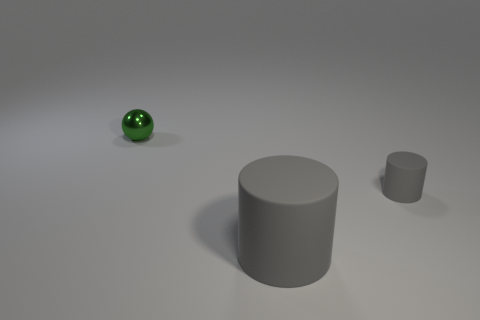There is another cylinder that is the same color as the big cylinder; what size is it?
Your response must be concise. Small. What color is the rubber cylinder that is the same size as the green thing?
Provide a short and direct response. Gray. Does the tiny metal sphere have the same color as the matte object that is behind the big cylinder?
Keep it short and to the point. No. There is a tiny thing on the right side of the green object; what is it made of?
Keep it short and to the point. Rubber. What is the size of the other object that is the same shape as the large object?
Your answer should be compact. Small. There is another rubber object that is the same shape as the small rubber thing; what is its color?
Make the answer very short. Gray. There is a tiny thing that is in front of the green metallic thing; is its color the same as the metal ball?
Offer a terse response. No. What is the shape of the big thing that is made of the same material as the small gray object?
Provide a succinct answer. Cylinder. What shape is the tiny object right of the tiny thing that is left of the thing right of the big gray cylinder?
Keep it short and to the point. Cylinder. Are there any objects to the right of the small thing that is on the left side of the large rubber cylinder?
Your answer should be compact. Yes. 